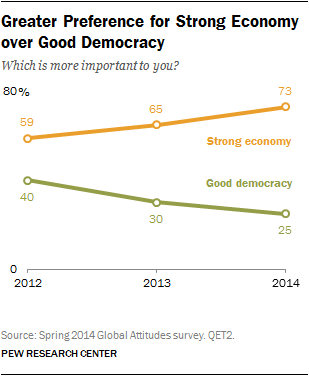Highlight a few significant elements in this photo. The ratio of change in the preference for a strong economy from 2012 to 2014 is 0.2373. The graph uses multiple colors to present the data. 